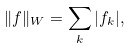<formula> <loc_0><loc_0><loc_500><loc_500>\| f \| _ { W } = \sum _ { k } | f _ { k } | ,</formula> 